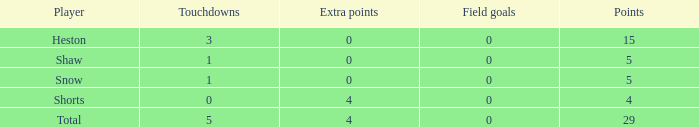What is the total number of field goals for a player that had less than 3 touchdowns, had 4 points, and had less than 4 extra points? 0.0. 